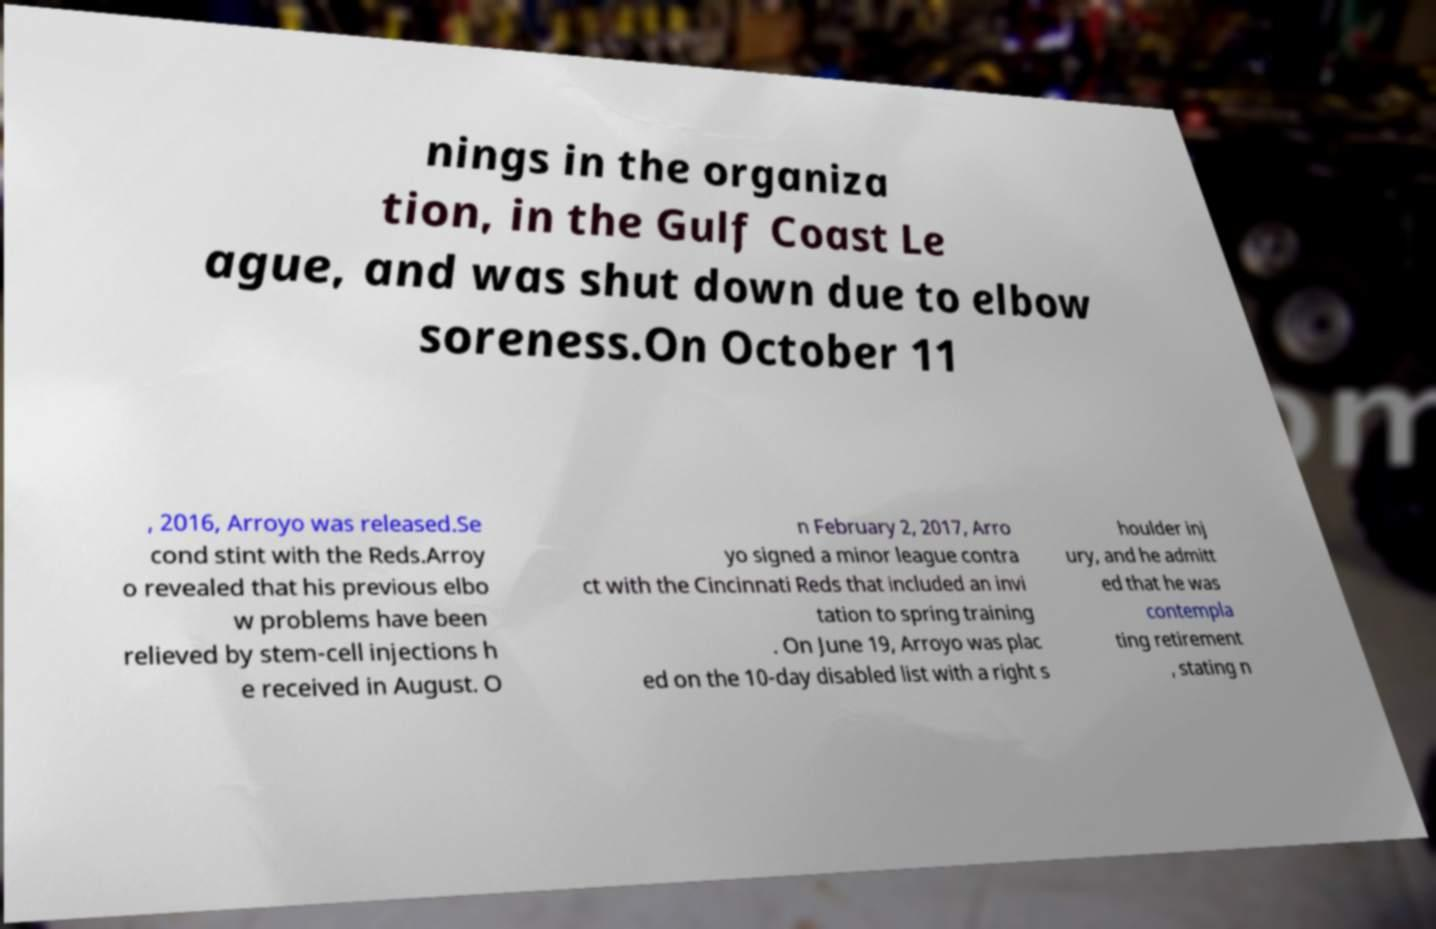Please read and relay the text visible in this image. What does it say? nings in the organiza tion, in the Gulf Coast Le ague, and was shut down due to elbow soreness.On October 11 , 2016, Arroyo was released.Se cond stint with the Reds.Arroy o revealed that his previous elbo w problems have been relieved by stem-cell injections h e received in August. O n February 2, 2017, Arro yo signed a minor league contra ct with the Cincinnati Reds that included an invi tation to spring training . On June 19, Arroyo was plac ed on the 10-day disabled list with a right s houlder inj ury, and he admitt ed that he was contempla ting retirement , stating n 